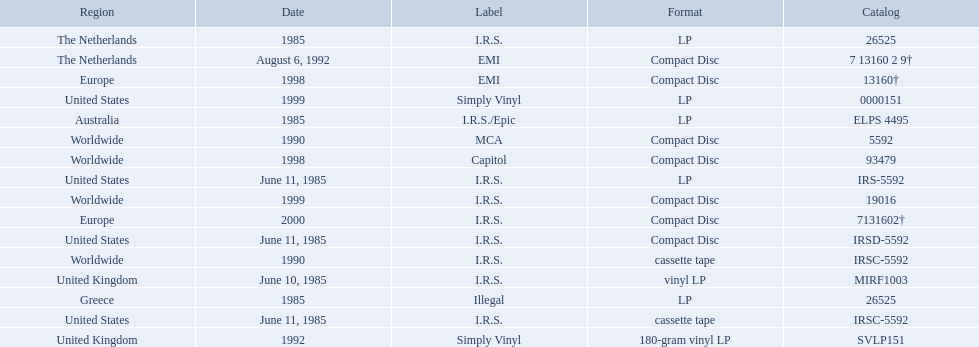Which dates were their releases by fables of the reconstruction? June 10, 1985, June 11, 1985, June 11, 1985, June 11, 1985, 1985, 1985, 1985, 1990, 1990, August 6, 1992, 1992, 1998, 1998, 1999, 1999, 2000. Which of these are in 1985? June 10, 1985, June 11, 1985, June 11, 1985, June 11, 1985, 1985, 1985, 1985. What regions were there releases on these dates? United Kingdom, United States, United States, United States, Greece, Australia, The Netherlands. Which of these are not greece? United Kingdom, United States, United States, United States, Australia, The Netherlands. Which of these regions have two labels listed? Australia. 